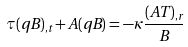Convert formula to latex. <formula><loc_0><loc_0><loc_500><loc_500>\tau ( q B ) _ { , t } + A ( q B ) = - \kappa \frac { ( A T ) _ { , r } } { B }</formula> 